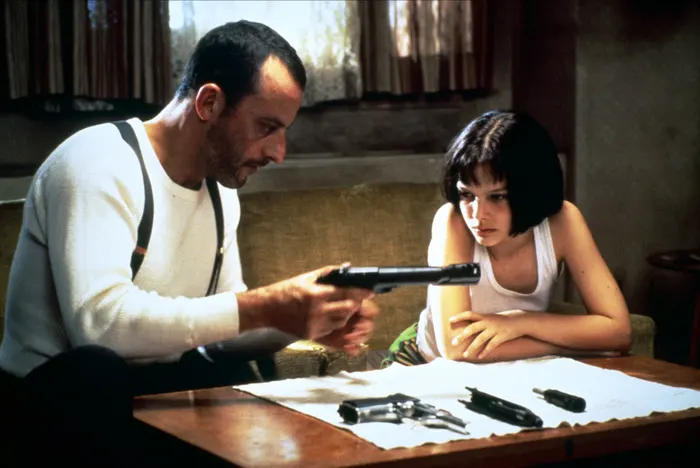Could you describe the props and setting in the image and speculate on their significance? In the image, the wooden table is scattered with several firearms, indicating a setting involved with violence or self-defense. The white paper on the table could be for taking notes or planning. Léon’s white tank top and black suspenders are simple yet practical attire, hinting at his utilitarian nature. Mathilda's white tank top and distinctive black choker suggest her rebellious demeanor and personal style. The beige wall and the small green plant in the background introduce a touch of normalcy and contrast the serious tone of the scene. Together, these elements suggest a covert training session or preparation for an impending confrontation, emphasizing the dangerous lives the characters lead. Imagine if this scene was set in a different period, say medieval times. How would the props and setting change? In a medieval setting, the table might be replaced with a rustic wooden bench. Instead of firearms, there would likely be an assortment of medieval weapons such as swords, daggers, and possibly a crossbow. Léon might be depicted wearing a tunic, with a belt where various weapons are sheathed. Mathilda could be in a simple, modest dress, possibly holding a small dagger. The window might be adorned with heavy drapes, and the plant replaced by a burning candle or an oil lamp, casting a dim, flickering light that heightens the sense of an impending battle or secretive training session. 